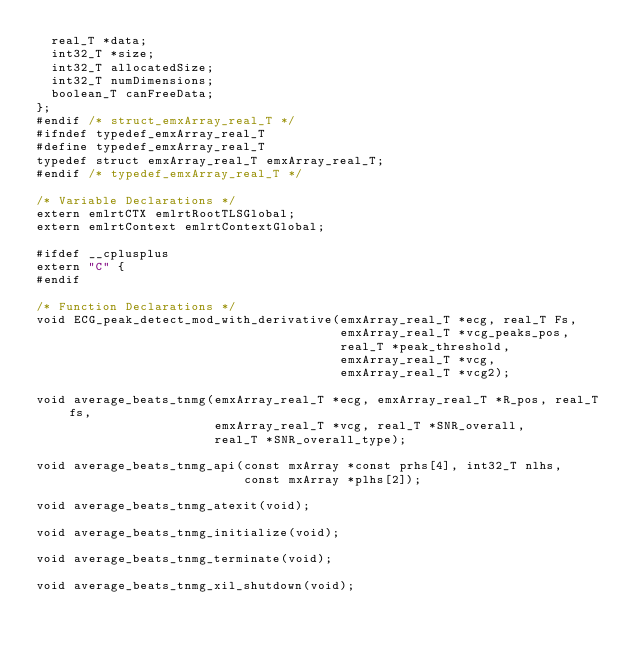Convert code to text. <code><loc_0><loc_0><loc_500><loc_500><_C_>  real_T *data;
  int32_T *size;
  int32_T allocatedSize;
  int32_T numDimensions;
  boolean_T canFreeData;
};
#endif /* struct_emxArray_real_T */
#ifndef typedef_emxArray_real_T
#define typedef_emxArray_real_T
typedef struct emxArray_real_T emxArray_real_T;
#endif /* typedef_emxArray_real_T */

/* Variable Declarations */
extern emlrtCTX emlrtRootTLSGlobal;
extern emlrtContext emlrtContextGlobal;

#ifdef __cplusplus
extern "C" {
#endif

/* Function Declarations */
void ECG_peak_detect_mod_with_derivative(emxArray_real_T *ecg, real_T Fs,
                                         emxArray_real_T *vcg_peaks_pos,
                                         real_T *peak_threshold,
                                         emxArray_real_T *vcg,
                                         emxArray_real_T *vcg2);

void average_beats_tnmg(emxArray_real_T *ecg, emxArray_real_T *R_pos, real_T fs,
                        emxArray_real_T *vcg, real_T *SNR_overall,
                        real_T *SNR_overall_type);

void average_beats_tnmg_api(const mxArray *const prhs[4], int32_T nlhs,
                            const mxArray *plhs[2]);

void average_beats_tnmg_atexit(void);

void average_beats_tnmg_initialize(void);

void average_beats_tnmg_terminate(void);

void average_beats_tnmg_xil_shutdown(void);
</code> 